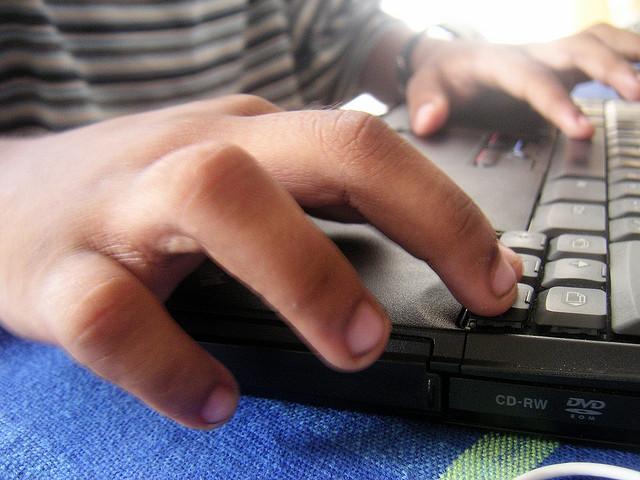Does this laptop have a DVD drive?
Keep it brief. Yes. What type of drive is it?
Give a very brief answer. Cd-rw. Is he playing a game or doing school work?
Keep it brief. Playing game. 